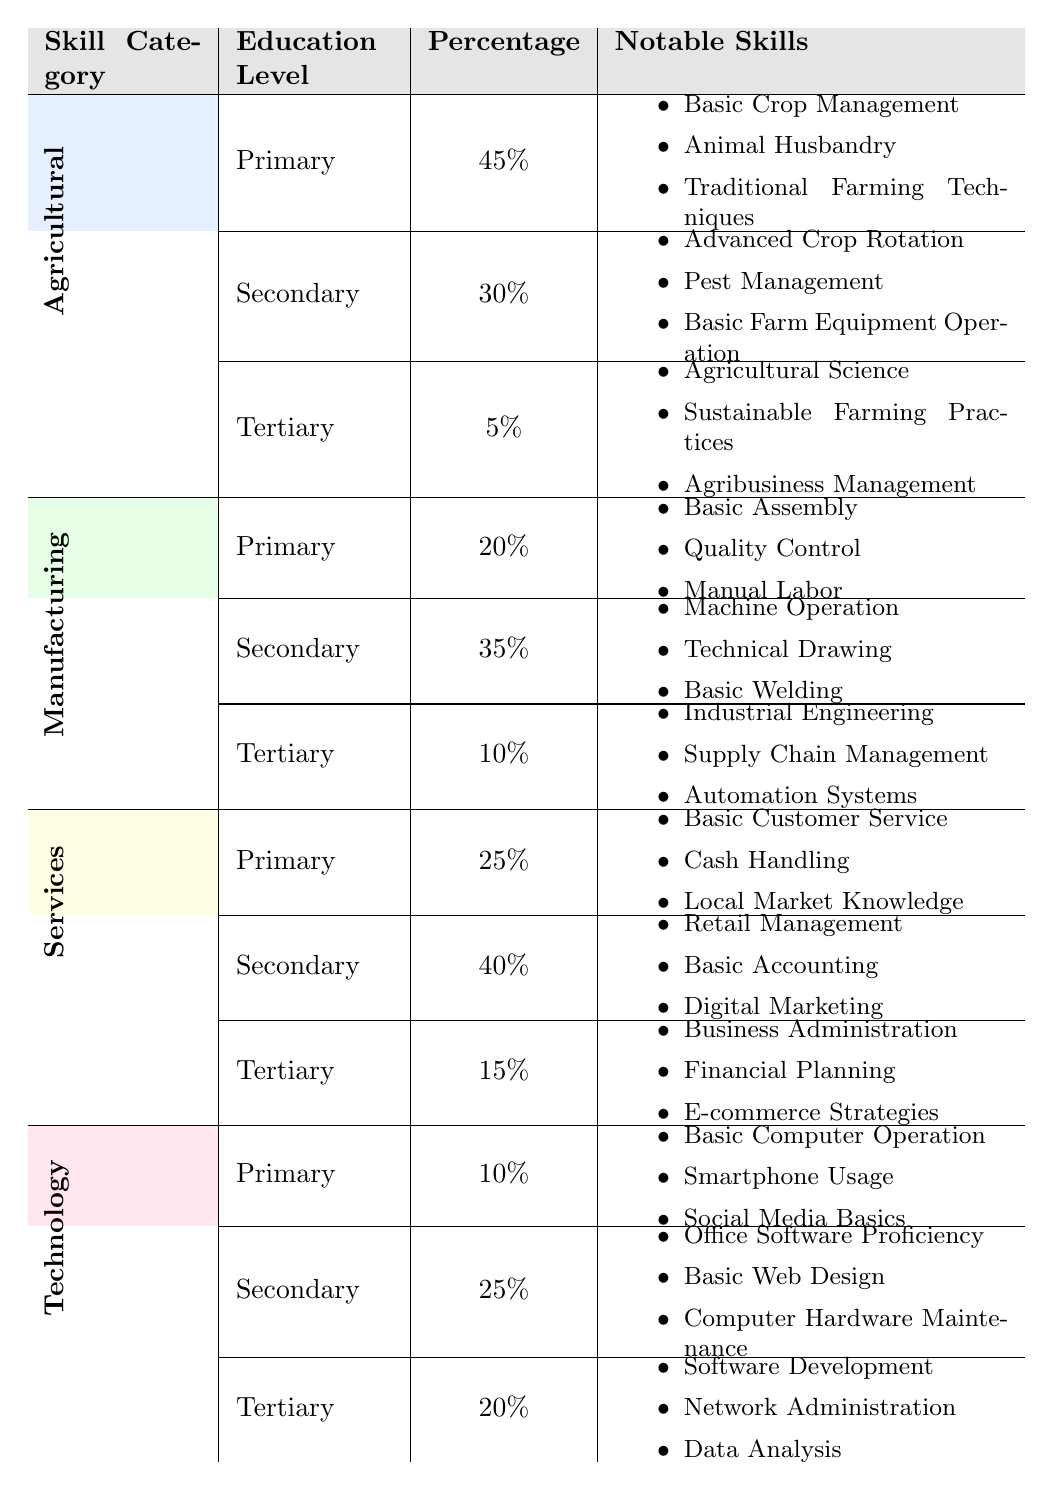What is the skill category with the highest percentage of primary education? The table indicates that the Agricultural category has the highest percentage at 45% for primary education.
Answer: Agricultural What percentage of the workforce has tertiary education in the Services category? The table shows that in the Services category, the percentage for tertiary education is 15%.
Answer: 15% What notable skill is associated with primary education in the Technology category? According to the table, notable skills for primary education in the Technology category include Basic Computer Operation, Smartphone Usage, and Social Media Basics.
Answer: Basic Computer Operation What is the total percentage of workforce with secondary education across all skill categories? To find the total percentage for secondary education, we sum the percentages: 30% (Agricultural) + 35% (Manufacturing) + 40% (Services) + 25% (Technology) = 130%.
Answer: 130% Which skill category has the highest overall percentage of workforce with tertiary education? The Technology category has the highest percentage of workforce with tertiary education at 20%, compared to 5% (Agricultural), 10% (Manufacturing), and 15% (Services).
Answer: Technology Is it true that more than 60% of workers in the Services category have either primary or secondary education? Yes, the total for Services is 25% (Primary) + 40% (Secondary) = 65%, which is greater than 60%.
Answer: Yes What percentage of the workforce in the Manufacturing category lacks secondary education? The table states that 20% has primary education and 10% has tertiary education, therefore 20% + 10% = 30% of the workforce in Manufacturing lacks secondary education.
Answer: 30% What is the difference in percentage between the secondary education level in Manufacturing and Services? The percentage for Manufacturing's secondary education is 35%, while for Services it is 40%. The difference is 40% - 35% = 5%.
Answer: 5% Are there more notable skills in the Agricultural category for tertiary education than in the Technology category for the same level? No, the Agricultural category shows 3 notable skills, while the Technology category also shows 3 notable skills, indicating they are equal.
Answer: No How does the primary education percentage in the Agricultural category compare to that in the Technology category? The Agricultural category has 45% for primary education, while the Technology category has 10%. The difference is 45% - 10% = 35%, indicating Agricultural is higher.
Answer: Agricultural is higher by 35% 